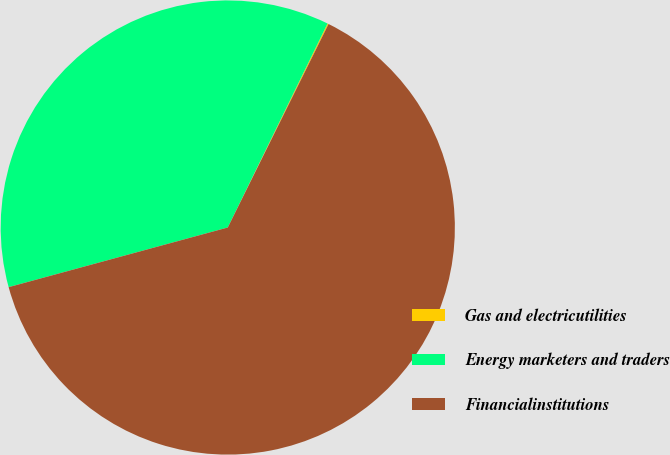Convert chart to OTSL. <chart><loc_0><loc_0><loc_500><loc_500><pie_chart><fcel>Gas and electricutilities<fcel>Energy marketers and traders<fcel>Financialinstitutions<nl><fcel>0.08%<fcel>36.47%<fcel>63.45%<nl></chart> 